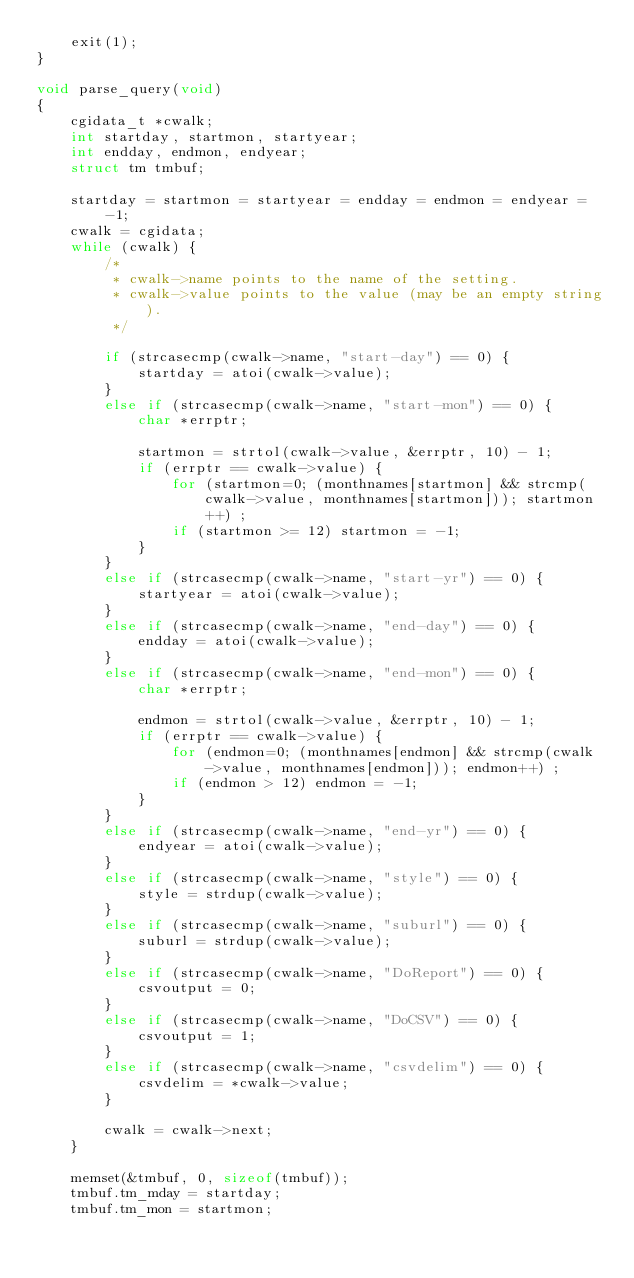Convert code to text. <code><loc_0><loc_0><loc_500><loc_500><_C_>	exit(1);
}

void parse_query(void)
{
	cgidata_t *cwalk;
	int startday, startmon, startyear;
	int endday, endmon, endyear;
	struct tm tmbuf;

	startday = startmon = startyear = endday = endmon = endyear = -1;
	cwalk = cgidata;
	while (cwalk) {
		/*
		 * cwalk->name points to the name of the setting.
		 * cwalk->value points to the value (may be an empty string).
		 */

		if (strcasecmp(cwalk->name, "start-day") == 0) {
			startday = atoi(cwalk->value);
		}
		else if (strcasecmp(cwalk->name, "start-mon") == 0) {
			char *errptr;

			startmon = strtol(cwalk->value, &errptr, 10) - 1;
			if (errptr == cwalk->value) {
				for (startmon=0; (monthnames[startmon] && strcmp(cwalk->value, monthnames[startmon])); startmon++) ;
				if (startmon >= 12) startmon = -1;
			}
		}
		else if (strcasecmp(cwalk->name, "start-yr") == 0) {
			startyear = atoi(cwalk->value);
		}
		else if (strcasecmp(cwalk->name, "end-day") == 0) {
			endday = atoi(cwalk->value);
		}
		else if (strcasecmp(cwalk->name, "end-mon") == 0) {
			char *errptr;

			endmon = strtol(cwalk->value, &errptr, 10) - 1;
			if (errptr == cwalk->value) {
				for (endmon=0; (monthnames[endmon] && strcmp(cwalk->value, monthnames[endmon])); endmon++) ;
				if (endmon > 12) endmon = -1;
			}
		}
		else if (strcasecmp(cwalk->name, "end-yr") == 0) {
			endyear = atoi(cwalk->value);
		}
		else if (strcasecmp(cwalk->name, "style") == 0) {
			style = strdup(cwalk->value);
		}
		else if (strcasecmp(cwalk->name, "suburl") == 0) {
			suburl = strdup(cwalk->value);
		}
		else if (strcasecmp(cwalk->name, "DoReport") == 0) {
			csvoutput = 0;
		}
		else if (strcasecmp(cwalk->name, "DoCSV") == 0) {
			csvoutput = 1;
		}
		else if (strcasecmp(cwalk->name, "csvdelim") == 0) {
			csvdelim = *cwalk->value;
		}

		cwalk = cwalk->next;
	}

	memset(&tmbuf, 0, sizeof(tmbuf));
	tmbuf.tm_mday = startday;
	tmbuf.tm_mon = startmon;</code> 